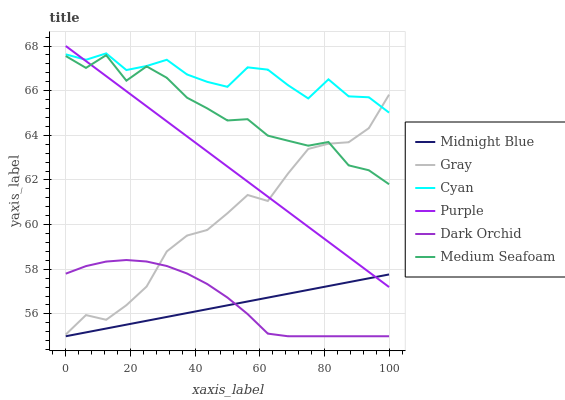Does Midnight Blue have the minimum area under the curve?
Answer yes or no. Yes. Does Cyan have the maximum area under the curve?
Answer yes or no. Yes. Does Purple have the minimum area under the curve?
Answer yes or no. No. Does Purple have the maximum area under the curve?
Answer yes or no. No. Is Midnight Blue the smoothest?
Answer yes or no. Yes. Is Medium Seafoam the roughest?
Answer yes or no. Yes. Is Purple the smoothest?
Answer yes or no. No. Is Purple the roughest?
Answer yes or no. No. Does Midnight Blue have the lowest value?
Answer yes or no. Yes. Does Purple have the lowest value?
Answer yes or no. No. Does Purple have the highest value?
Answer yes or no. Yes. Does Midnight Blue have the highest value?
Answer yes or no. No. Is Dark Orchid less than Medium Seafoam?
Answer yes or no. Yes. Is Gray greater than Midnight Blue?
Answer yes or no. Yes. Does Dark Orchid intersect Midnight Blue?
Answer yes or no. Yes. Is Dark Orchid less than Midnight Blue?
Answer yes or no. No. Is Dark Orchid greater than Midnight Blue?
Answer yes or no. No. Does Dark Orchid intersect Medium Seafoam?
Answer yes or no. No. 